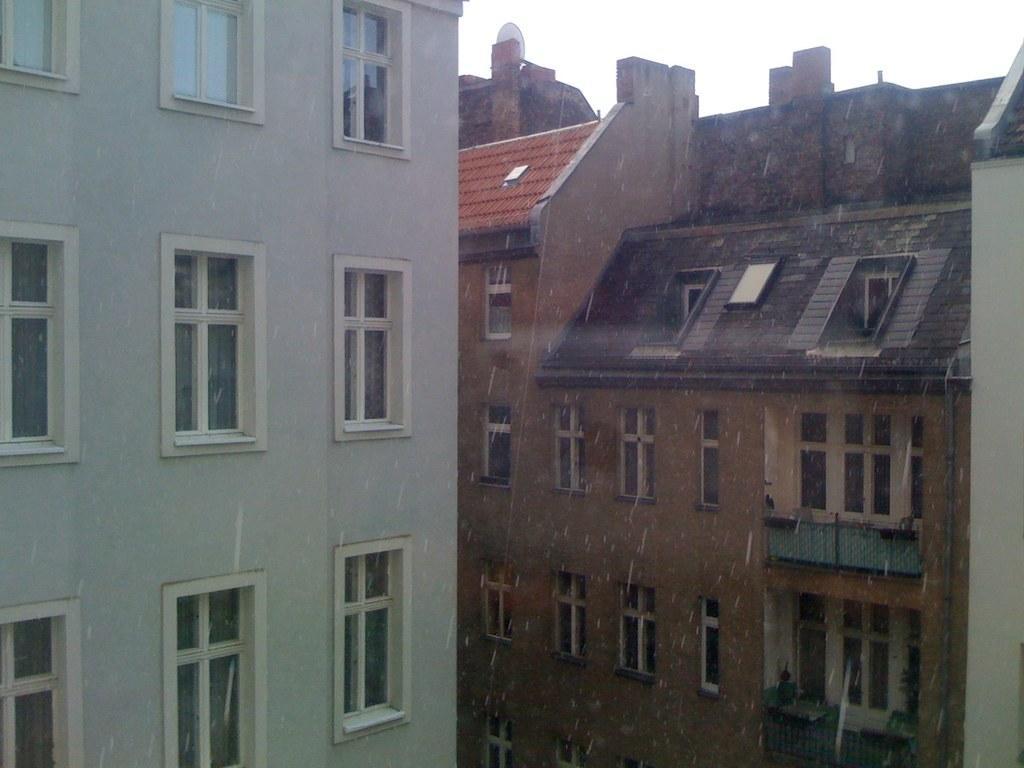Please provide a concise description of this image. In this image I can see few buildings and number of windows. 